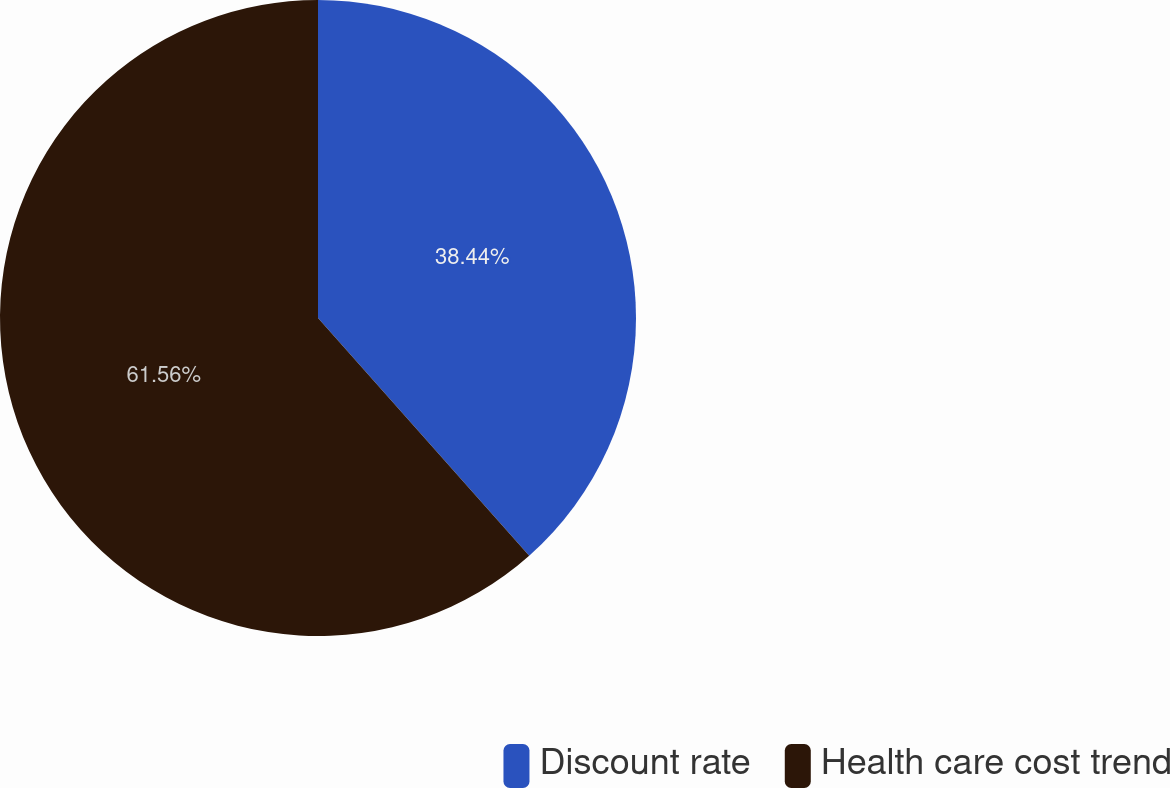Convert chart to OTSL. <chart><loc_0><loc_0><loc_500><loc_500><pie_chart><fcel>Discount rate<fcel>Health care cost trend<nl><fcel>38.44%<fcel>61.56%<nl></chart> 